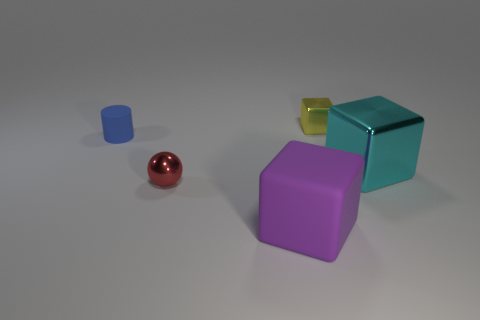Subtract all purple cylinders. Subtract all green blocks. How many cylinders are left? 1 Add 3 tiny brown blocks. How many objects exist? 8 Subtract all spheres. How many objects are left? 4 Add 4 matte blocks. How many matte blocks are left? 5 Add 3 small matte cubes. How many small matte cubes exist? 3 Subtract 1 cyan blocks. How many objects are left? 4 Subtract all large cyan metal things. Subtract all large rubber cubes. How many objects are left? 3 